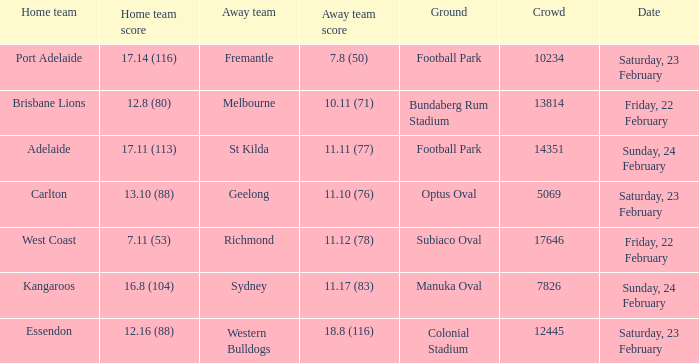On what date did the away team Fremantle play? Saturday, 23 February. 